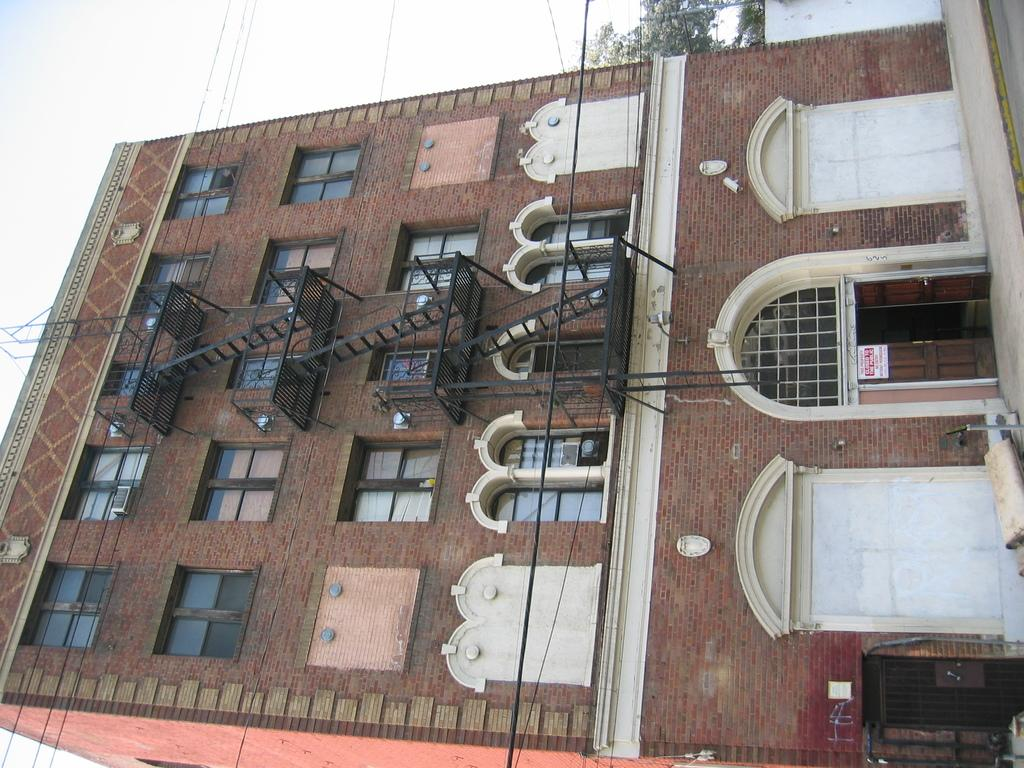What type of building is in the image? There is a brick building in the image. What features can be seen on the building? There are doors, windows, and stairs visible on the building. Are there any additional structures or elements in the image? Yes, there are wires and trees in the image. What can be seen in the background of the image? The sky and trees are visible in the background of the image. What type of beef is being prepared in the stew in the image? There is no beef or stew present in the image; it features a brick building with doors, windows, stairs, wires, trees, and a visible sky in the background. What is the quiver used for in the image? There is no quiver present in the image. 